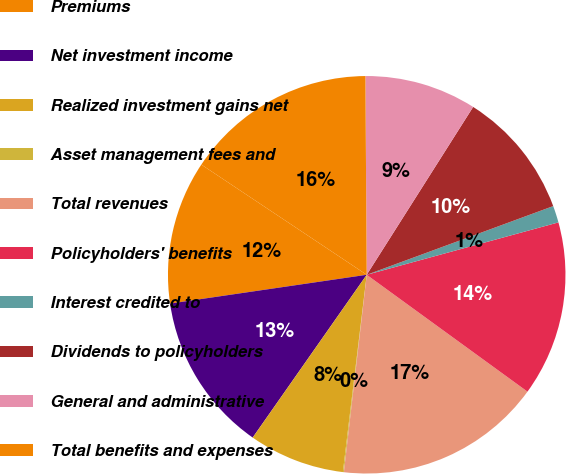<chart> <loc_0><loc_0><loc_500><loc_500><pie_chart><fcel>Premiums<fcel>Net investment income<fcel>Realized investment gains net<fcel>Asset management fees and<fcel>Total revenues<fcel>Policyholders' benefits<fcel>Interest credited to<fcel>Dividends to policyholders<fcel>General and administrative<fcel>Total benefits and expenses<nl><fcel>11.67%<fcel>12.96%<fcel>7.81%<fcel>0.08%<fcel>16.83%<fcel>14.25%<fcel>1.37%<fcel>10.39%<fcel>9.1%<fcel>15.54%<nl></chart> 